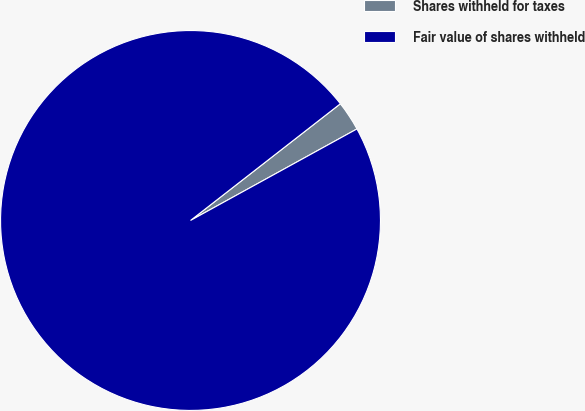Convert chart to OTSL. <chart><loc_0><loc_0><loc_500><loc_500><pie_chart><fcel>Shares withheld for taxes<fcel>Fair value of shares withheld<nl><fcel>2.53%<fcel>97.47%<nl></chart> 